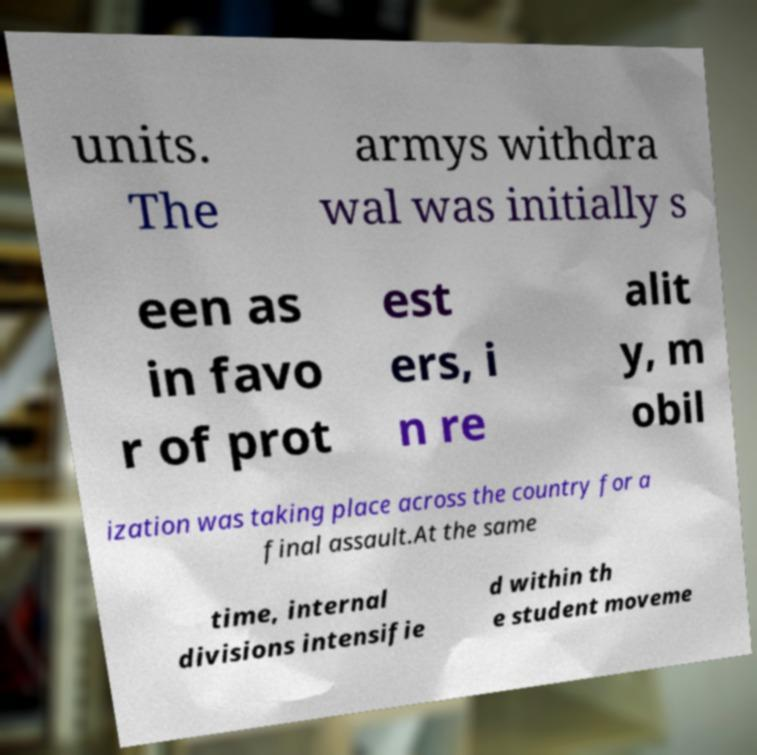Can you accurately transcribe the text from the provided image for me? units. The armys withdra wal was initially s een as in favo r of prot est ers, i n re alit y, m obil ization was taking place across the country for a final assault.At the same time, internal divisions intensifie d within th e student moveme 